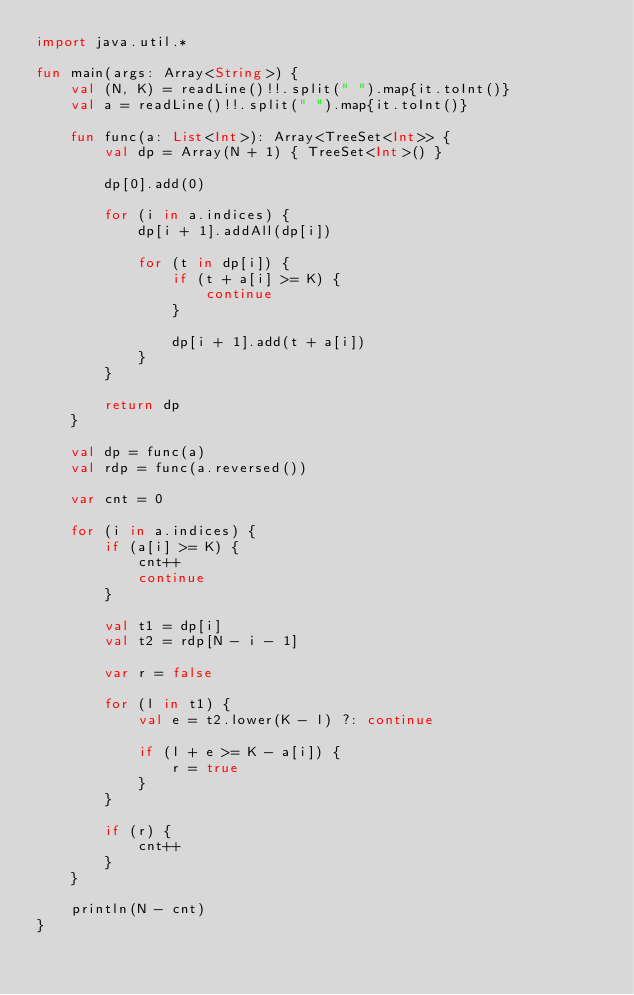<code> <loc_0><loc_0><loc_500><loc_500><_Kotlin_>import java.util.*

fun main(args: Array<String>) {
    val (N, K) = readLine()!!.split(" ").map{it.toInt()}
    val a = readLine()!!.split(" ").map{it.toInt()}

    fun func(a: List<Int>): Array<TreeSet<Int>> {
        val dp = Array(N + 1) { TreeSet<Int>() }

        dp[0].add(0)

        for (i in a.indices) {
            dp[i + 1].addAll(dp[i])

            for (t in dp[i]) {
                if (t + a[i] >= K) {
                    continue
                }

                dp[i + 1].add(t + a[i])
            }
        }

        return dp
    }

    val dp = func(a)
    val rdp = func(a.reversed())

    var cnt = 0

    for (i in a.indices) {
        if (a[i] >= K) {
            cnt++
            continue
        }

        val t1 = dp[i]
        val t2 = rdp[N - i - 1]

        var r = false

        for (l in t1) {
            val e = t2.lower(K - l) ?: continue

            if (l + e >= K - a[i]) {
                r = true
            }
        }

        if (r) {
            cnt++
        }
    }

    println(N - cnt)
}
</code> 